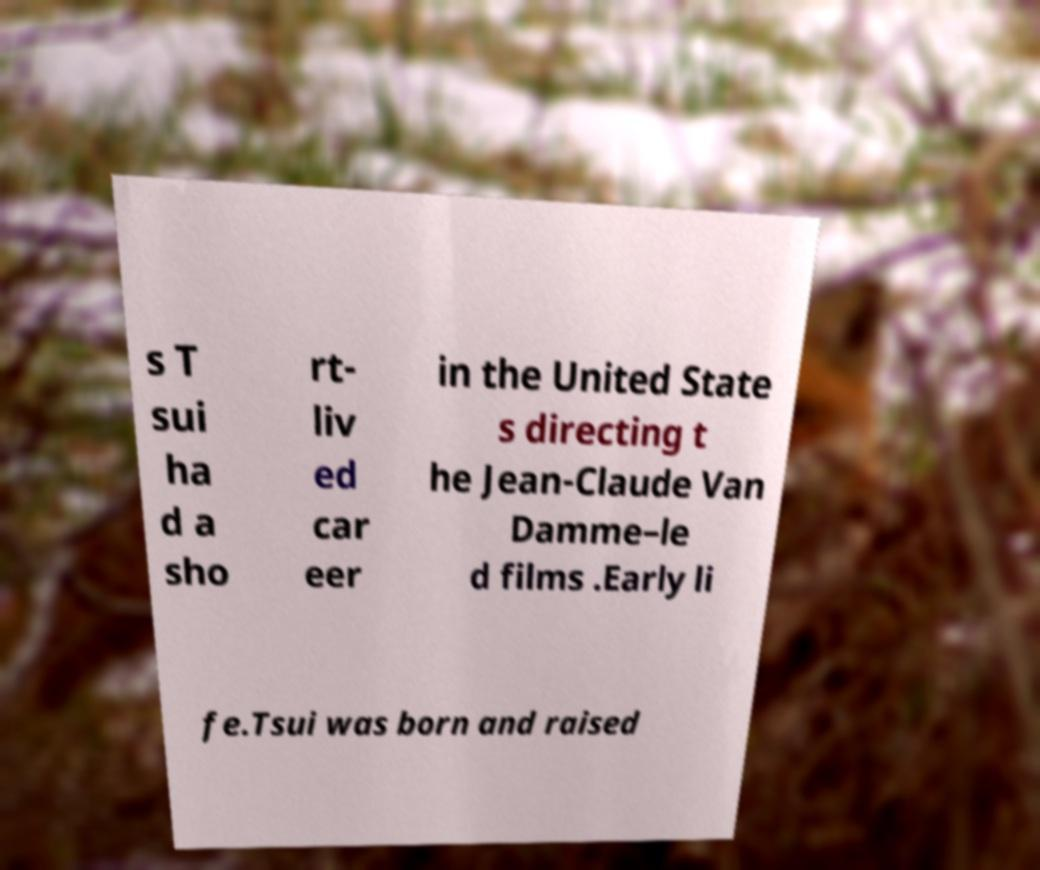Could you assist in decoding the text presented in this image and type it out clearly? s T sui ha d a sho rt- liv ed car eer in the United State s directing t he Jean-Claude Van Damme–le d films .Early li fe.Tsui was born and raised 